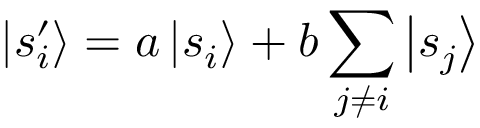Convert formula to latex. <formula><loc_0><loc_0><loc_500><loc_500>\left | s _ { i } ^ { \prime } \right \rangle = a \left | s _ { i } \right \rangle + b \sum _ { j \neq i } \left | s _ { j } \right \rangle</formula> 